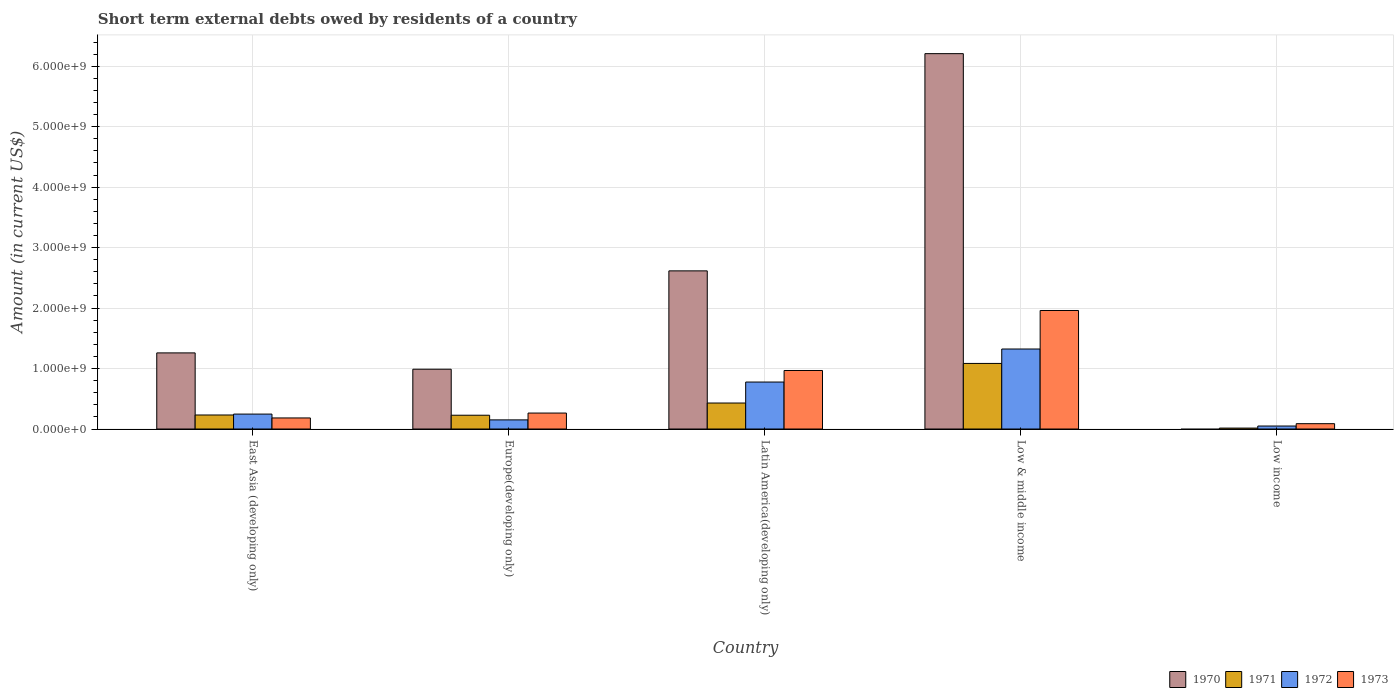How many different coloured bars are there?
Offer a very short reply. 4. Are the number of bars on each tick of the X-axis equal?
Your response must be concise. No. How many bars are there on the 1st tick from the left?
Your response must be concise. 4. What is the label of the 2nd group of bars from the left?
Provide a succinct answer. Europe(developing only). What is the amount of short-term external debts owed by residents in 1972 in East Asia (developing only)?
Offer a very short reply. 2.47e+08. Across all countries, what is the maximum amount of short-term external debts owed by residents in 1973?
Provide a short and direct response. 1.96e+09. Across all countries, what is the minimum amount of short-term external debts owed by residents in 1972?
Make the answer very short. 4.94e+07. What is the total amount of short-term external debts owed by residents in 1970 in the graph?
Give a very brief answer. 1.11e+1. What is the difference between the amount of short-term external debts owed by residents in 1972 in Latin America(developing only) and that in Low income?
Provide a short and direct response. 7.28e+08. What is the difference between the amount of short-term external debts owed by residents in 1970 in Europe(developing only) and the amount of short-term external debts owed by residents in 1972 in Low income?
Provide a short and direct response. 9.40e+08. What is the average amount of short-term external debts owed by residents in 1973 per country?
Make the answer very short. 6.93e+08. What is the difference between the amount of short-term external debts owed by residents of/in 1970 and amount of short-term external debts owed by residents of/in 1971 in East Asia (developing only)?
Provide a short and direct response. 1.03e+09. In how many countries, is the amount of short-term external debts owed by residents in 1973 greater than 1600000000 US$?
Make the answer very short. 1. What is the ratio of the amount of short-term external debts owed by residents in 1970 in East Asia (developing only) to that in Europe(developing only)?
Provide a succinct answer. 1.27. What is the difference between the highest and the second highest amount of short-term external debts owed by residents in 1971?
Your answer should be compact. 8.53e+08. What is the difference between the highest and the lowest amount of short-term external debts owed by residents in 1970?
Your answer should be compact. 6.21e+09. In how many countries, is the amount of short-term external debts owed by residents in 1973 greater than the average amount of short-term external debts owed by residents in 1973 taken over all countries?
Provide a succinct answer. 2. Is it the case that in every country, the sum of the amount of short-term external debts owed by residents in 1970 and amount of short-term external debts owed by residents in 1973 is greater than the sum of amount of short-term external debts owed by residents in 1972 and amount of short-term external debts owed by residents in 1971?
Ensure brevity in your answer.  No. Is it the case that in every country, the sum of the amount of short-term external debts owed by residents in 1973 and amount of short-term external debts owed by residents in 1972 is greater than the amount of short-term external debts owed by residents in 1971?
Offer a very short reply. Yes. How many bars are there?
Keep it short and to the point. 19. Are all the bars in the graph horizontal?
Your response must be concise. No. What is the difference between two consecutive major ticks on the Y-axis?
Your answer should be compact. 1.00e+09. Are the values on the major ticks of Y-axis written in scientific E-notation?
Offer a terse response. Yes. Does the graph contain any zero values?
Provide a succinct answer. Yes. How are the legend labels stacked?
Ensure brevity in your answer.  Horizontal. What is the title of the graph?
Keep it short and to the point. Short term external debts owed by residents of a country. Does "1969" appear as one of the legend labels in the graph?
Your answer should be compact. No. What is the Amount (in current US$) of 1970 in East Asia (developing only)?
Your answer should be compact. 1.26e+09. What is the Amount (in current US$) of 1971 in East Asia (developing only)?
Give a very brief answer. 2.32e+08. What is the Amount (in current US$) in 1972 in East Asia (developing only)?
Provide a short and direct response. 2.47e+08. What is the Amount (in current US$) of 1973 in East Asia (developing only)?
Your response must be concise. 1.83e+08. What is the Amount (in current US$) in 1970 in Europe(developing only)?
Keep it short and to the point. 9.89e+08. What is the Amount (in current US$) of 1971 in Europe(developing only)?
Keep it short and to the point. 2.28e+08. What is the Amount (in current US$) of 1972 in Europe(developing only)?
Make the answer very short. 1.51e+08. What is the Amount (in current US$) in 1973 in Europe(developing only)?
Offer a very short reply. 2.64e+08. What is the Amount (in current US$) in 1970 in Latin America(developing only)?
Offer a very short reply. 2.62e+09. What is the Amount (in current US$) in 1971 in Latin America(developing only)?
Provide a short and direct response. 4.30e+08. What is the Amount (in current US$) in 1972 in Latin America(developing only)?
Offer a terse response. 7.77e+08. What is the Amount (in current US$) of 1973 in Latin America(developing only)?
Ensure brevity in your answer.  9.68e+08. What is the Amount (in current US$) of 1970 in Low & middle income?
Give a very brief answer. 6.21e+09. What is the Amount (in current US$) in 1971 in Low & middle income?
Ensure brevity in your answer.  1.08e+09. What is the Amount (in current US$) in 1972 in Low & middle income?
Your answer should be compact. 1.32e+09. What is the Amount (in current US$) in 1973 in Low & middle income?
Ensure brevity in your answer.  1.96e+09. What is the Amount (in current US$) in 1970 in Low income?
Provide a succinct answer. 0. What is the Amount (in current US$) in 1971 in Low income?
Provide a succinct answer. 1.54e+07. What is the Amount (in current US$) of 1972 in Low income?
Your response must be concise. 4.94e+07. What is the Amount (in current US$) of 1973 in Low income?
Make the answer very short. 8.84e+07. Across all countries, what is the maximum Amount (in current US$) in 1970?
Your response must be concise. 6.21e+09. Across all countries, what is the maximum Amount (in current US$) in 1971?
Ensure brevity in your answer.  1.08e+09. Across all countries, what is the maximum Amount (in current US$) in 1972?
Your response must be concise. 1.32e+09. Across all countries, what is the maximum Amount (in current US$) in 1973?
Your response must be concise. 1.96e+09. Across all countries, what is the minimum Amount (in current US$) of 1970?
Your answer should be very brief. 0. Across all countries, what is the minimum Amount (in current US$) of 1971?
Your answer should be compact. 1.54e+07. Across all countries, what is the minimum Amount (in current US$) of 1972?
Keep it short and to the point. 4.94e+07. Across all countries, what is the minimum Amount (in current US$) of 1973?
Provide a succinct answer. 8.84e+07. What is the total Amount (in current US$) in 1970 in the graph?
Provide a short and direct response. 1.11e+1. What is the total Amount (in current US$) in 1971 in the graph?
Offer a terse response. 1.99e+09. What is the total Amount (in current US$) in 1972 in the graph?
Give a very brief answer. 2.55e+09. What is the total Amount (in current US$) in 1973 in the graph?
Provide a short and direct response. 3.46e+09. What is the difference between the Amount (in current US$) of 1970 in East Asia (developing only) and that in Europe(developing only)?
Your answer should be very brief. 2.70e+08. What is the difference between the Amount (in current US$) in 1972 in East Asia (developing only) and that in Europe(developing only)?
Offer a very short reply. 9.60e+07. What is the difference between the Amount (in current US$) of 1973 in East Asia (developing only) and that in Europe(developing only)?
Your answer should be compact. -8.10e+07. What is the difference between the Amount (in current US$) of 1970 in East Asia (developing only) and that in Latin America(developing only)?
Provide a succinct answer. -1.36e+09. What is the difference between the Amount (in current US$) of 1971 in East Asia (developing only) and that in Latin America(developing only)?
Offer a terse response. -1.98e+08. What is the difference between the Amount (in current US$) in 1972 in East Asia (developing only) and that in Latin America(developing only)?
Give a very brief answer. -5.30e+08. What is the difference between the Amount (in current US$) of 1973 in East Asia (developing only) and that in Latin America(developing only)?
Your answer should be very brief. -7.85e+08. What is the difference between the Amount (in current US$) in 1970 in East Asia (developing only) and that in Low & middle income?
Provide a succinct answer. -4.95e+09. What is the difference between the Amount (in current US$) in 1971 in East Asia (developing only) and that in Low & middle income?
Your answer should be very brief. -8.53e+08. What is the difference between the Amount (in current US$) of 1972 in East Asia (developing only) and that in Low & middle income?
Your answer should be compact. -1.08e+09. What is the difference between the Amount (in current US$) in 1973 in East Asia (developing only) and that in Low & middle income?
Offer a very short reply. -1.78e+09. What is the difference between the Amount (in current US$) of 1971 in East Asia (developing only) and that in Low income?
Ensure brevity in your answer.  2.17e+08. What is the difference between the Amount (in current US$) of 1972 in East Asia (developing only) and that in Low income?
Ensure brevity in your answer.  1.98e+08. What is the difference between the Amount (in current US$) in 1973 in East Asia (developing only) and that in Low income?
Offer a very short reply. 9.46e+07. What is the difference between the Amount (in current US$) in 1970 in Europe(developing only) and that in Latin America(developing only)?
Make the answer very short. -1.63e+09. What is the difference between the Amount (in current US$) of 1971 in Europe(developing only) and that in Latin America(developing only)?
Make the answer very short. -2.02e+08. What is the difference between the Amount (in current US$) in 1972 in Europe(developing only) and that in Latin America(developing only)?
Your response must be concise. -6.26e+08. What is the difference between the Amount (in current US$) of 1973 in Europe(developing only) and that in Latin America(developing only)?
Give a very brief answer. -7.04e+08. What is the difference between the Amount (in current US$) of 1970 in Europe(developing only) and that in Low & middle income?
Ensure brevity in your answer.  -5.22e+09. What is the difference between the Amount (in current US$) of 1971 in Europe(developing only) and that in Low & middle income?
Keep it short and to the point. -8.57e+08. What is the difference between the Amount (in current US$) of 1972 in Europe(developing only) and that in Low & middle income?
Offer a terse response. -1.17e+09. What is the difference between the Amount (in current US$) in 1973 in Europe(developing only) and that in Low & middle income?
Your answer should be compact. -1.70e+09. What is the difference between the Amount (in current US$) in 1971 in Europe(developing only) and that in Low income?
Give a very brief answer. 2.13e+08. What is the difference between the Amount (in current US$) in 1972 in Europe(developing only) and that in Low income?
Make the answer very short. 1.02e+08. What is the difference between the Amount (in current US$) in 1973 in Europe(developing only) and that in Low income?
Your answer should be very brief. 1.76e+08. What is the difference between the Amount (in current US$) in 1970 in Latin America(developing only) and that in Low & middle income?
Give a very brief answer. -3.59e+09. What is the difference between the Amount (in current US$) of 1971 in Latin America(developing only) and that in Low & middle income?
Ensure brevity in your answer.  -6.55e+08. What is the difference between the Amount (in current US$) of 1972 in Latin America(developing only) and that in Low & middle income?
Provide a succinct answer. -5.46e+08. What is the difference between the Amount (in current US$) of 1973 in Latin America(developing only) and that in Low & middle income?
Your answer should be very brief. -9.92e+08. What is the difference between the Amount (in current US$) of 1971 in Latin America(developing only) and that in Low income?
Your response must be concise. 4.15e+08. What is the difference between the Amount (in current US$) in 1972 in Latin America(developing only) and that in Low income?
Your answer should be very brief. 7.28e+08. What is the difference between the Amount (in current US$) in 1973 in Latin America(developing only) and that in Low income?
Your answer should be very brief. 8.80e+08. What is the difference between the Amount (in current US$) of 1971 in Low & middle income and that in Low income?
Your response must be concise. 1.07e+09. What is the difference between the Amount (in current US$) of 1972 in Low & middle income and that in Low income?
Provide a short and direct response. 1.27e+09. What is the difference between the Amount (in current US$) of 1973 in Low & middle income and that in Low income?
Your answer should be compact. 1.87e+09. What is the difference between the Amount (in current US$) of 1970 in East Asia (developing only) and the Amount (in current US$) of 1971 in Europe(developing only)?
Offer a very short reply. 1.03e+09. What is the difference between the Amount (in current US$) in 1970 in East Asia (developing only) and the Amount (in current US$) in 1972 in Europe(developing only)?
Your answer should be very brief. 1.11e+09. What is the difference between the Amount (in current US$) in 1970 in East Asia (developing only) and the Amount (in current US$) in 1973 in Europe(developing only)?
Your response must be concise. 9.95e+08. What is the difference between the Amount (in current US$) of 1971 in East Asia (developing only) and the Amount (in current US$) of 1972 in Europe(developing only)?
Offer a terse response. 8.10e+07. What is the difference between the Amount (in current US$) of 1971 in East Asia (developing only) and the Amount (in current US$) of 1973 in Europe(developing only)?
Your answer should be very brief. -3.20e+07. What is the difference between the Amount (in current US$) in 1972 in East Asia (developing only) and the Amount (in current US$) in 1973 in Europe(developing only)?
Provide a short and direct response. -1.70e+07. What is the difference between the Amount (in current US$) in 1970 in East Asia (developing only) and the Amount (in current US$) in 1971 in Latin America(developing only)?
Your response must be concise. 8.29e+08. What is the difference between the Amount (in current US$) in 1970 in East Asia (developing only) and the Amount (in current US$) in 1972 in Latin America(developing only)?
Offer a very short reply. 4.82e+08. What is the difference between the Amount (in current US$) in 1970 in East Asia (developing only) and the Amount (in current US$) in 1973 in Latin America(developing only)?
Offer a very short reply. 2.91e+08. What is the difference between the Amount (in current US$) in 1971 in East Asia (developing only) and the Amount (in current US$) in 1972 in Latin America(developing only)?
Give a very brief answer. -5.45e+08. What is the difference between the Amount (in current US$) in 1971 in East Asia (developing only) and the Amount (in current US$) in 1973 in Latin America(developing only)?
Make the answer very short. -7.36e+08. What is the difference between the Amount (in current US$) in 1972 in East Asia (developing only) and the Amount (in current US$) in 1973 in Latin America(developing only)?
Ensure brevity in your answer.  -7.21e+08. What is the difference between the Amount (in current US$) of 1970 in East Asia (developing only) and the Amount (in current US$) of 1971 in Low & middle income?
Ensure brevity in your answer.  1.74e+08. What is the difference between the Amount (in current US$) in 1970 in East Asia (developing only) and the Amount (in current US$) in 1972 in Low & middle income?
Ensure brevity in your answer.  -6.43e+07. What is the difference between the Amount (in current US$) in 1970 in East Asia (developing only) and the Amount (in current US$) in 1973 in Low & middle income?
Ensure brevity in your answer.  -7.01e+08. What is the difference between the Amount (in current US$) of 1971 in East Asia (developing only) and the Amount (in current US$) of 1972 in Low & middle income?
Offer a very short reply. -1.09e+09. What is the difference between the Amount (in current US$) in 1971 in East Asia (developing only) and the Amount (in current US$) in 1973 in Low & middle income?
Offer a terse response. -1.73e+09. What is the difference between the Amount (in current US$) of 1972 in East Asia (developing only) and the Amount (in current US$) of 1973 in Low & middle income?
Make the answer very short. -1.71e+09. What is the difference between the Amount (in current US$) of 1970 in East Asia (developing only) and the Amount (in current US$) of 1971 in Low income?
Ensure brevity in your answer.  1.24e+09. What is the difference between the Amount (in current US$) of 1970 in East Asia (developing only) and the Amount (in current US$) of 1972 in Low income?
Offer a very short reply. 1.21e+09. What is the difference between the Amount (in current US$) of 1970 in East Asia (developing only) and the Amount (in current US$) of 1973 in Low income?
Your response must be concise. 1.17e+09. What is the difference between the Amount (in current US$) of 1971 in East Asia (developing only) and the Amount (in current US$) of 1972 in Low income?
Ensure brevity in your answer.  1.83e+08. What is the difference between the Amount (in current US$) in 1971 in East Asia (developing only) and the Amount (in current US$) in 1973 in Low income?
Provide a succinct answer. 1.44e+08. What is the difference between the Amount (in current US$) of 1972 in East Asia (developing only) and the Amount (in current US$) of 1973 in Low income?
Offer a very short reply. 1.59e+08. What is the difference between the Amount (in current US$) of 1970 in Europe(developing only) and the Amount (in current US$) of 1971 in Latin America(developing only)?
Your response must be concise. 5.59e+08. What is the difference between the Amount (in current US$) in 1970 in Europe(developing only) and the Amount (in current US$) in 1972 in Latin America(developing only)?
Give a very brief answer. 2.12e+08. What is the difference between the Amount (in current US$) in 1970 in Europe(developing only) and the Amount (in current US$) in 1973 in Latin America(developing only)?
Provide a short and direct response. 2.10e+07. What is the difference between the Amount (in current US$) in 1971 in Europe(developing only) and the Amount (in current US$) in 1972 in Latin America(developing only)?
Provide a succinct answer. -5.49e+08. What is the difference between the Amount (in current US$) in 1971 in Europe(developing only) and the Amount (in current US$) in 1973 in Latin America(developing only)?
Give a very brief answer. -7.40e+08. What is the difference between the Amount (in current US$) in 1972 in Europe(developing only) and the Amount (in current US$) in 1973 in Latin America(developing only)?
Your response must be concise. -8.17e+08. What is the difference between the Amount (in current US$) in 1970 in Europe(developing only) and the Amount (in current US$) in 1971 in Low & middle income?
Offer a terse response. -9.58e+07. What is the difference between the Amount (in current US$) in 1970 in Europe(developing only) and the Amount (in current US$) in 1972 in Low & middle income?
Keep it short and to the point. -3.34e+08. What is the difference between the Amount (in current US$) in 1970 in Europe(developing only) and the Amount (in current US$) in 1973 in Low & middle income?
Your answer should be compact. -9.71e+08. What is the difference between the Amount (in current US$) in 1971 in Europe(developing only) and the Amount (in current US$) in 1972 in Low & middle income?
Your answer should be very brief. -1.10e+09. What is the difference between the Amount (in current US$) of 1971 in Europe(developing only) and the Amount (in current US$) of 1973 in Low & middle income?
Give a very brief answer. -1.73e+09. What is the difference between the Amount (in current US$) in 1972 in Europe(developing only) and the Amount (in current US$) in 1973 in Low & middle income?
Make the answer very short. -1.81e+09. What is the difference between the Amount (in current US$) of 1970 in Europe(developing only) and the Amount (in current US$) of 1971 in Low income?
Offer a terse response. 9.74e+08. What is the difference between the Amount (in current US$) in 1970 in Europe(developing only) and the Amount (in current US$) in 1972 in Low income?
Your response must be concise. 9.40e+08. What is the difference between the Amount (in current US$) of 1970 in Europe(developing only) and the Amount (in current US$) of 1973 in Low income?
Your response must be concise. 9.01e+08. What is the difference between the Amount (in current US$) in 1971 in Europe(developing only) and the Amount (in current US$) in 1972 in Low income?
Give a very brief answer. 1.79e+08. What is the difference between the Amount (in current US$) in 1971 in Europe(developing only) and the Amount (in current US$) in 1973 in Low income?
Ensure brevity in your answer.  1.40e+08. What is the difference between the Amount (in current US$) of 1972 in Europe(developing only) and the Amount (in current US$) of 1973 in Low income?
Provide a succinct answer. 6.26e+07. What is the difference between the Amount (in current US$) of 1970 in Latin America(developing only) and the Amount (in current US$) of 1971 in Low & middle income?
Your answer should be very brief. 1.53e+09. What is the difference between the Amount (in current US$) in 1970 in Latin America(developing only) and the Amount (in current US$) in 1972 in Low & middle income?
Offer a very short reply. 1.29e+09. What is the difference between the Amount (in current US$) of 1970 in Latin America(developing only) and the Amount (in current US$) of 1973 in Low & middle income?
Make the answer very short. 6.55e+08. What is the difference between the Amount (in current US$) in 1971 in Latin America(developing only) and the Amount (in current US$) in 1972 in Low & middle income?
Your answer should be compact. -8.93e+08. What is the difference between the Amount (in current US$) of 1971 in Latin America(developing only) and the Amount (in current US$) of 1973 in Low & middle income?
Ensure brevity in your answer.  -1.53e+09. What is the difference between the Amount (in current US$) of 1972 in Latin America(developing only) and the Amount (in current US$) of 1973 in Low & middle income?
Give a very brief answer. -1.18e+09. What is the difference between the Amount (in current US$) in 1970 in Latin America(developing only) and the Amount (in current US$) in 1971 in Low income?
Your answer should be compact. 2.60e+09. What is the difference between the Amount (in current US$) in 1970 in Latin America(developing only) and the Amount (in current US$) in 1972 in Low income?
Make the answer very short. 2.57e+09. What is the difference between the Amount (in current US$) of 1970 in Latin America(developing only) and the Amount (in current US$) of 1973 in Low income?
Ensure brevity in your answer.  2.53e+09. What is the difference between the Amount (in current US$) of 1971 in Latin America(developing only) and the Amount (in current US$) of 1972 in Low income?
Your answer should be very brief. 3.81e+08. What is the difference between the Amount (in current US$) in 1971 in Latin America(developing only) and the Amount (in current US$) in 1973 in Low income?
Offer a very short reply. 3.42e+08. What is the difference between the Amount (in current US$) in 1972 in Latin America(developing only) and the Amount (in current US$) in 1973 in Low income?
Ensure brevity in your answer.  6.89e+08. What is the difference between the Amount (in current US$) in 1970 in Low & middle income and the Amount (in current US$) in 1971 in Low income?
Give a very brief answer. 6.19e+09. What is the difference between the Amount (in current US$) in 1970 in Low & middle income and the Amount (in current US$) in 1972 in Low income?
Your answer should be very brief. 6.16e+09. What is the difference between the Amount (in current US$) of 1970 in Low & middle income and the Amount (in current US$) of 1973 in Low income?
Provide a succinct answer. 6.12e+09. What is the difference between the Amount (in current US$) in 1971 in Low & middle income and the Amount (in current US$) in 1972 in Low income?
Ensure brevity in your answer.  1.04e+09. What is the difference between the Amount (in current US$) of 1971 in Low & middle income and the Amount (in current US$) of 1973 in Low income?
Make the answer very short. 9.96e+08. What is the difference between the Amount (in current US$) of 1972 in Low & middle income and the Amount (in current US$) of 1973 in Low income?
Your answer should be very brief. 1.23e+09. What is the average Amount (in current US$) of 1970 per country?
Your answer should be very brief. 2.21e+09. What is the average Amount (in current US$) in 1971 per country?
Offer a terse response. 3.98e+08. What is the average Amount (in current US$) of 1972 per country?
Keep it short and to the point. 5.10e+08. What is the average Amount (in current US$) of 1973 per country?
Provide a succinct answer. 6.93e+08. What is the difference between the Amount (in current US$) of 1970 and Amount (in current US$) of 1971 in East Asia (developing only)?
Offer a very short reply. 1.03e+09. What is the difference between the Amount (in current US$) of 1970 and Amount (in current US$) of 1972 in East Asia (developing only)?
Offer a very short reply. 1.01e+09. What is the difference between the Amount (in current US$) in 1970 and Amount (in current US$) in 1973 in East Asia (developing only)?
Give a very brief answer. 1.08e+09. What is the difference between the Amount (in current US$) in 1971 and Amount (in current US$) in 1972 in East Asia (developing only)?
Your answer should be compact. -1.50e+07. What is the difference between the Amount (in current US$) in 1971 and Amount (in current US$) in 1973 in East Asia (developing only)?
Your answer should be very brief. 4.90e+07. What is the difference between the Amount (in current US$) in 1972 and Amount (in current US$) in 1973 in East Asia (developing only)?
Offer a very short reply. 6.40e+07. What is the difference between the Amount (in current US$) of 1970 and Amount (in current US$) of 1971 in Europe(developing only)?
Make the answer very short. 7.61e+08. What is the difference between the Amount (in current US$) of 1970 and Amount (in current US$) of 1972 in Europe(developing only)?
Your answer should be very brief. 8.38e+08. What is the difference between the Amount (in current US$) in 1970 and Amount (in current US$) in 1973 in Europe(developing only)?
Offer a very short reply. 7.25e+08. What is the difference between the Amount (in current US$) of 1971 and Amount (in current US$) of 1972 in Europe(developing only)?
Your response must be concise. 7.70e+07. What is the difference between the Amount (in current US$) in 1971 and Amount (in current US$) in 1973 in Europe(developing only)?
Give a very brief answer. -3.60e+07. What is the difference between the Amount (in current US$) in 1972 and Amount (in current US$) in 1973 in Europe(developing only)?
Ensure brevity in your answer.  -1.13e+08. What is the difference between the Amount (in current US$) in 1970 and Amount (in current US$) in 1971 in Latin America(developing only)?
Give a very brief answer. 2.19e+09. What is the difference between the Amount (in current US$) in 1970 and Amount (in current US$) in 1972 in Latin America(developing only)?
Give a very brief answer. 1.84e+09. What is the difference between the Amount (in current US$) of 1970 and Amount (in current US$) of 1973 in Latin America(developing only)?
Make the answer very short. 1.65e+09. What is the difference between the Amount (in current US$) in 1971 and Amount (in current US$) in 1972 in Latin America(developing only)?
Offer a very short reply. -3.47e+08. What is the difference between the Amount (in current US$) in 1971 and Amount (in current US$) in 1973 in Latin America(developing only)?
Your response must be concise. -5.38e+08. What is the difference between the Amount (in current US$) in 1972 and Amount (in current US$) in 1973 in Latin America(developing only)?
Your answer should be compact. -1.91e+08. What is the difference between the Amount (in current US$) of 1970 and Amount (in current US$) of 1971 in Low & middle income?
Give a very brief answer. 5.12e+09. What is the difference between the Amount (in current US$) in 1970 and Amount (in current US$) in 1972 in Low & middle income?
Your answer should be very brief. 4.89e+09. What is the difference between the Amount (in current US$) in 1970 and Amount (in current US$) in 1973 in Low & middle income?
Your answer should be compact. 4.25e+09. What is the difference between the Amount (in current US$) of 1971 and Amount (in current US$) of 1972 in Low & middle income?
Give a very brief answer. -2.39e+08. What is the difference between the Amount (in current US$) of 1971 and Amount (in current US$) of 1973 in Low & middle income?
Your answer should be very brief. -8.76e+08. What is the difference between the Amount (in current US$) of 1972 and Amount (in current US$) of 1973 in Low & middle income?
Your answer should be very brief. -6.37e+08. What is the difference between the Amount (in current US$) of 1971 and Amount (in current US$) of 1972 in Low income?
Provide a short and direct response. -3.40e+07. What is the difference between the Amount (in current US$) of 1971 and Amount (in current US$) of 1973 in Low income?
Ensure brevity in your answer.  -7.30e+07. What is the difference between the Amount (in current US$) in 1972 and Amount (in current US$) in 1973 in Low income?
Your answer should be compact. -3.90e+07. What is the ratio of the Amount (in current US$) in 1970 in East Asia (developing only) to that in Europe(developing only)?
Offer a very short reply. 1.27. What is the ratio of the Amount (in current US$) of 1971 in East Asia (developing only) to that in Europe(developing only)?
Offer a very short reply. 1.02. What is the ratio of the Amount (in current US$) of 1972 in East Asia (developing only) to that in Europe(developing only)?
Keep it short and to the point. 1.64. What is the ratio of the Amount (in current US$) of 1973 in East Asia (developing only) to that in Europe(developing only)?
Ensure brevity in your answer.  0.69. What is the ratio of the Amount (in current US$) of 1970 in East Asia (developing only) to that in Latin America(developing only)?
Offer a very short reply. 0.48. What is the ratio of the Amount (in current US$) of 1971 in East Asia (developing only) to that in Latin America(developing only)?
Provide a succinct answer. 0.54. What is the ratio of the Amount (in current US$) in 1972 in East Asia (developing only) to that in Latin America(developing only)?
Make the answer very short. 0.32. What is the ratio of the Amount (in current US$) of 1973 in East Asia (developing only) to that in Latin America(developing only)?
Provide a succinct answer. 0.19. What is the ratio of the Amount (in current US$) of 1970 in East Asia (developing only) to that in Low & middle income?
Offer a very short reply. 0.2. What is the ratio of the Amount (in current US$) of 1971 in East Asia (developing only) to that in Low & middle income?
Provide a short and direct response. 0.21. What is the ratio of the Amount (in current US$) in 1972 in East Asia (developing only) to that in Low & middle income?
Keep it short and to the point. 0.19. What is the ratio of the Amount (in current US$) in 1973 in East Asia (developing only) to that in Low & middle income?
Keep it short and to the point. 0.09. What is the ratio of the Amount (in current US$) in 1971 in East Asia (developing only) to that in Low income?
Your answer should be very brief. 15.11. What is the ratio of the Amount (in current US$) in 1972 in East Asia (developing only) to that in Low income?
Your answer should be compact. 5. What is the ratio of the Amount (in current US$) of 1973 in East Asia (developing only) to that in Low income?
Offer a terse response. 2.07. What is the ratio of the Amount (in current US$) of 1970 in Europe(developing only) to that in Latin America(developing only)?
Your response must be concise. 0.38. What is the ratio of the Amount (in current US$) of 1971 in Europe(developing only) to that in Latin America(developing only)?
Keep it short and to the point. 0.53. What is the ratio of the Amount (in current US$) of 1972 in Europe(developing only) to that in Latin America(developing only)?
Your response must be concise. 0.19. What is the ratio of the Amount (in current US$) in 1973 in Europe(developing only) to that in Latin America(developing only)?
Ensure brevity in your answer.  0.27. What is the ratio of the Amount (in current US$) of 1970 in Europe(developing only) to that in Low & middle income?
Offer a terse response. 0.16. What is the ratio of the Amount (in current US$) in 1971 in Europe(developing only) to that in Low & middle income?
Make the answer very short. 0.21. What is the ratio of the Amount (in current US$) in 1972 in Europe(developing only) to that in Low & middle income?
Offer a terse response. 0.11. What is the ratio of the Amount (in current US$) in 1973 in Europe(developing only) to that in Low & middle income?
Keep it short and to the point. 0.13. What is the ratio of the Amount (in current US$) of 1971 in Europe(developing only) to that in Low income?
Give a very brief answer. 14.85. What is the ratio of the Amount (in current US$) of 1972 in Europe(developing only) to that in Low income?
Your answer should be compact. 3.06. What is the ratio of the Amount (in current US$) of 1973 in Europe(developing only) to that in Low income?
Ensure brevity in your answer.  2.99. What is the ratio of the Amount (in current US$) of 1970 in Latin America(developing only) to that in Low & middle income?
Keep it short and to the point. 0.42. What is the ratio of the Amount (in current US$) of 1971 in Latin America(developing only) to that in Low & middle income?
Offer a terse response. 0.4. What is the ratio of the Amount (in current US$) in 1972 in Latin America(developing only) to that in Low & middle income?
Provide a succinct answer. 0.59. What is the ratio of the Amount (in current US$) of 1973 in Latin America(developing only) to that in Low & middle income?
Offer a very short reply. 0.49. What is the ratio of the Amount (in current US$) in 1971 in Latin America(developing only) to that in Low income?
Make the answer very short. 28.01. What is the ratio of the Amount (in current US$) of 1972 in Latin America(developing only) to that in Low income?
Your answer should be very brief. 15.74. What is the ratio of the Amount (in current US$) of 1973 in Latin America(developing only) to that in Low income?
Offer a very short reply. 10.96. What is the ratio of the Amount (in current US$) of 1971 in Low & middle income to that in Low income?
Your answer should be compact. 70.65. What is the ratio of the Amount (in current US$) of 1972 in Low & middle income to that in Low income?
Ensure brevity in your answer.  26.81. What is the ratio of the Amount (in current US$) in 1973 in Low & middle income to that in Low income?
Make the answer very short. 22.19. What is the difference between the highest and the second highest Amount (in current US$) of 1970?
Your answer should be compact. 3.59e+09. What is the difference between the highest and the second highest Amount (in current US$) of 1971?
Provide a short and direct response. 6.55e+08. What is the difference between the highest and the second highest Amount (in current US$) in 1972?
Offer a very short reply. 5.46e+08. What is the difference between the highest and the second highest Amount (in current US$) of 1973?
Keep it short and to the point. 9.92e+08. What is the difference between the highest and the lowest Amount (in current US$) in 1970?
Offer a terse response. 6.21e+09. What is the difference between the highest and the lowest Amount (in current US$) of 1971?
Make the answer very short. 1.07e+09. What is the difference between the highest and the lowest Amount (in current US$) of 1972?
Provide a short and direct response. 1.27e+09. What is the difference between the highest and the lowest Amount (in current US$) in 1973?
Offer a terse response. 1.87e+09. 